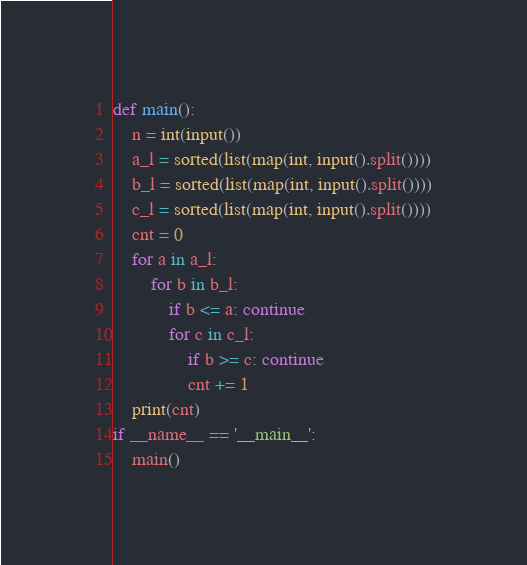Convert code to text. <code><loc_0><loc_0><loc_500><loc_500><_Python_>def main():
    n = int(input())
    a_l = sorted(list(map(int, input().split())))
    b_l = sorted(list(map(int, input().split())))
    c_l = sorted(list(map(int, input().split())))
    cnt = 0
    for a in a_l:
        for b in b_l:
            if b <= a: continue
            for c in c_l:
                if b >= c: continue
                cnt += 1
    print(cnt)
if __name__ == '__main__':
    main()</code> 